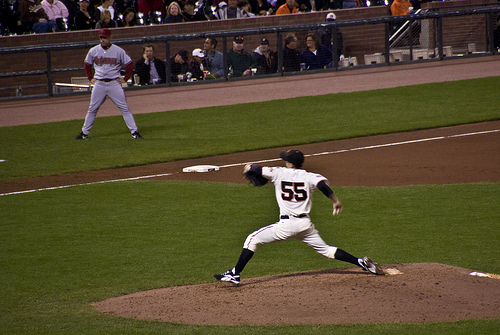What message might this image convey about teamwork and dedication? This image beautifully illustrates the essence of teamwork and dedication. The pitcher, fully focused and in motion, symbolizes the individual effort and skill that contribute to the team's success. The coach and the player in the background represent the supportive roles and strategic thinking essential in a collaborative effort. Together, they embody the collective determination and hard work required to achieve a common goal in sports and beyond. 